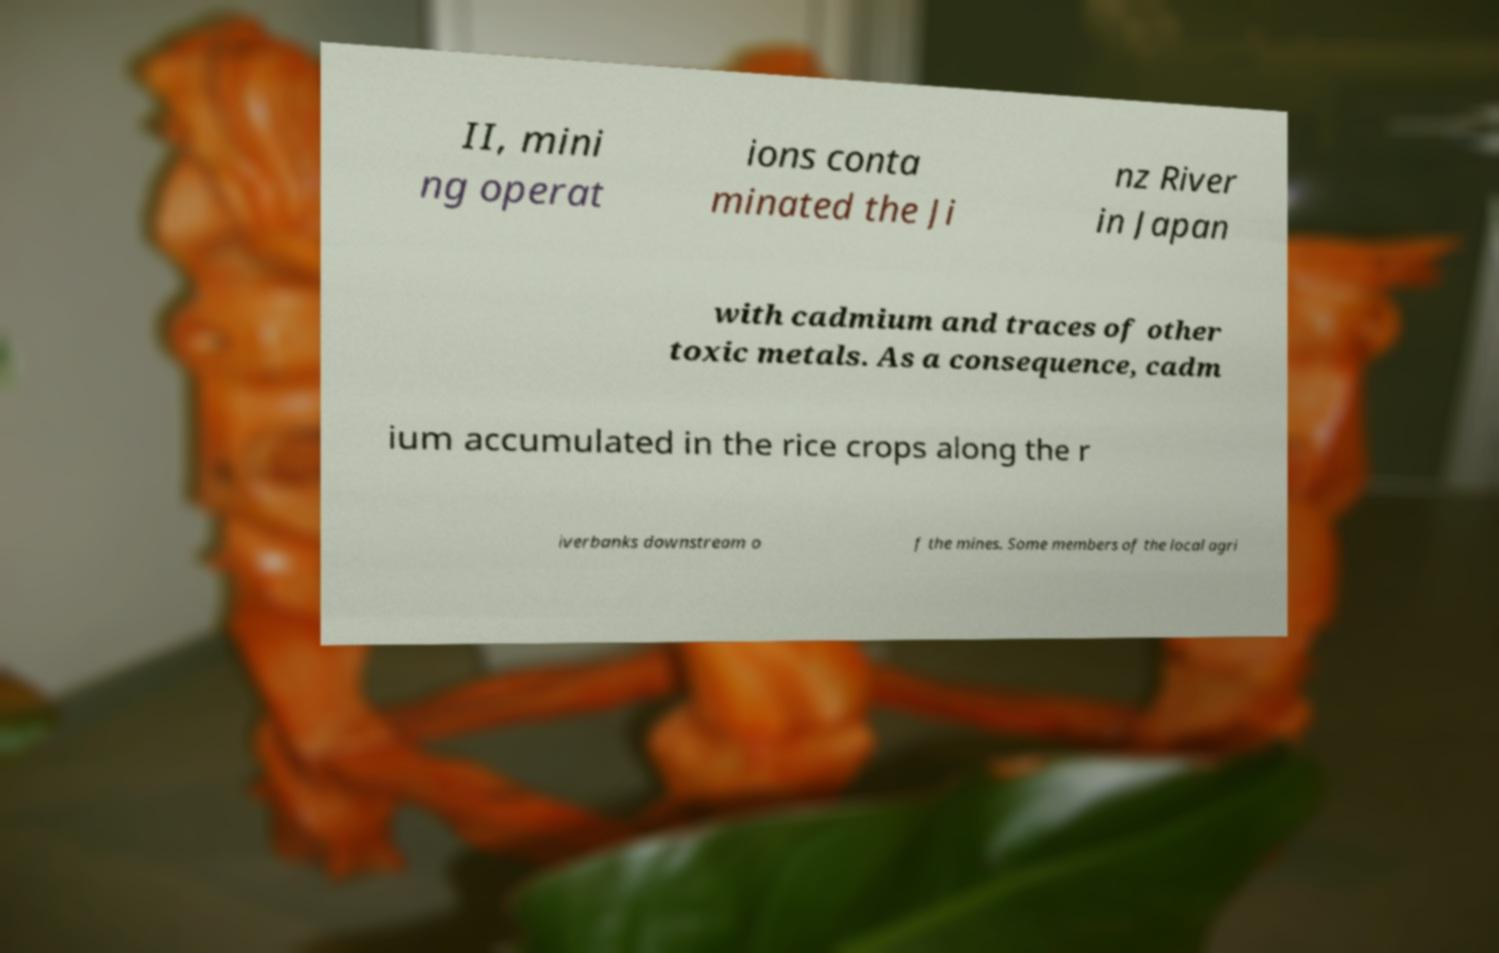For documentation purposes, I need the text within this image transcribed. Could you provide that? II, mini ng operat ions conta minated the Ji nz River in Japan with cadmium and traces of other toxic metals. As a consequence, cadm ium accumulated in the rice crops along the r iverbanks downstream o f the mines. Some members of the local agri 